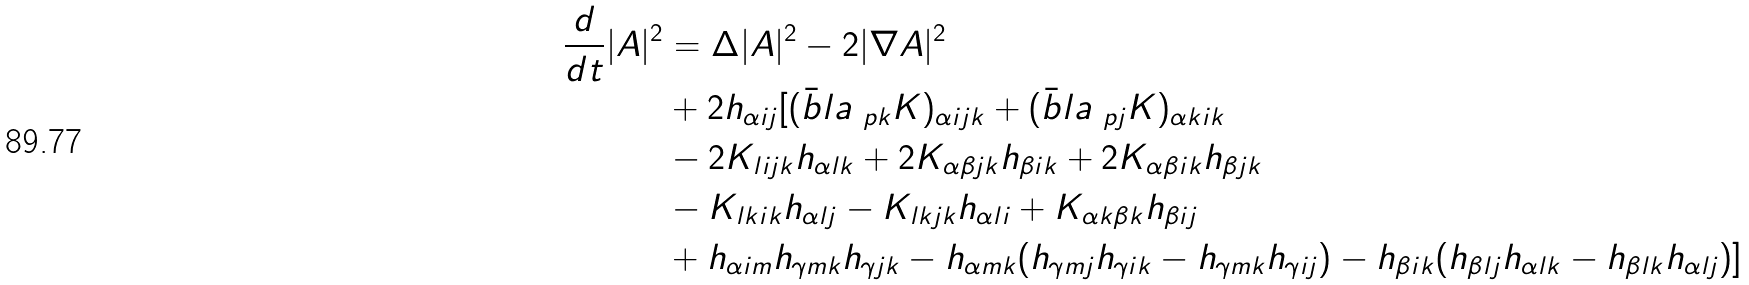<formula> <loc_0><loc_0><loc_500><loc_500>\frac { d } { d t } | A | ^ { 2 } & = \Delta | A | ^ { 2 } - 2 | \nabla A | ^ { 2 } \\ & + 2 h _ { \alpha i j } [ ( \bar { b } l a _ { \ p k } K ) _ { \alpha i j k } + ( \bar { b } l a _ { \ p j } K ) _ { \alpha k i k } \\ & - 2 K _ { l i j k } h _ { \alpha l k } + 2 K _ { \alpha \beta j k } h _ { \beta i k } + 2 K _ { \alpha \beta i k } h _ { \beta j k } \\ & - K _ { l k i k } h _ { \alpha l j } - K _ { l k j k } h _ { \alpha l i } + K _ { \alpha k \beta k } h _ { \beta i j } \\ & + h _ { \alpha i m } h _ { \gamma m k } h _ { \gamma j k } - h _ { \alpha m k } ( h _ { \gamma m j } h _ { \gamma i k } - h _ { \gamma m k } h _ { \gamma i j } ) - h _ { \beta i k } ( h _ { \beta l j } h _ { \alpha l k } - h _ { \beta l k } h _ { \alpha l j } ) ]</formula> 